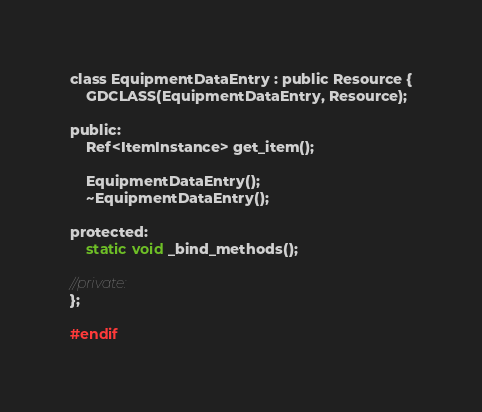Convert code to text. <code><loc_0><loc_0><loc_500><loc_500><_C_>
class EquipmentDataEntry : public Resource {
	GDCLASS(EquipmentDataEntry, Resource);

public:
	Ref<ItemInstance> get_item();

	EquipmentDataEntry();
	~EquipmentDataEntry();

protected:
	static void _bind_methods();

//private:
};

#endif
</code> 